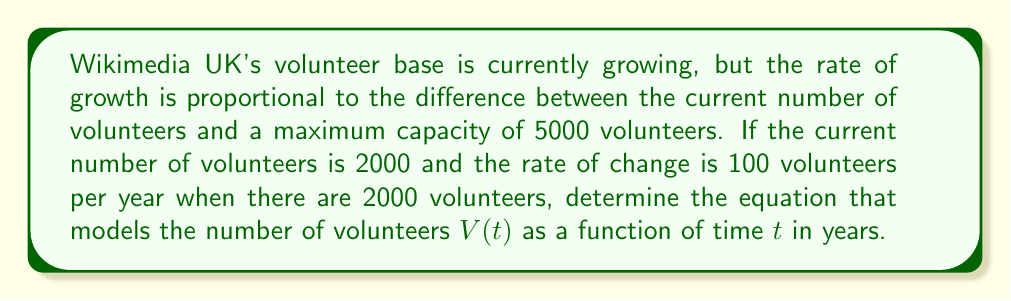What is the answer to this math problem? Let's approach this step-by-step:

1) We can model this situation with a first-order differential equation:

   $$\frac{dV}{dt} = k(5000 - V)$$

   where $k$ is a constant of proportionality.

2) We're given that when $V = 2000$, $\frac{dV}{dt} = 100$. Let's use this to find $k$:

   $$100 = k(5000 - 2000)$$
   $$100 = 3000k$$
   $$k = \frac{1}{30}$$

3) Now our differential equation is:

   $$\frac{dV}{dt} = \frac{1}{30}(5000 - V)$$

4) This is a separable differential equation. Let's separate the variables:

   $$\frac{dV}{5000 - V} = \frac{1}{30}dt$$

5) Integrate both sides:

   $$-\ln|5000 - V| = \frac{1}{30}t + C$$

6) Solve for V:

   $$5000 - V = e^{-(\frac{1}{30}t + C)}$$
   $$V = 5000 - Ae^{-\frac{t}{30}}$$

   where $A = e^C$

7) Use the initial condition that $V(0) = 2000$ to find $A$:

   $$2000 = 5000 - A$$
   $$A = 3000$$

Therefore, the equation that models the number of volunteers is:

$$V(t) = 5000 - 3000e^{-\frac{t}{30}}$$
Answer: $$V(t) = 5000 - 3000e^{-\frac{t}{30}}$$ 